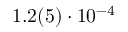Convert formula to latex. <formula><loc_0><loc_0><loc_500><loc_500>1 . 2 ( 5 ) \cdot 1 0 ^ { - 4 }</formula> 